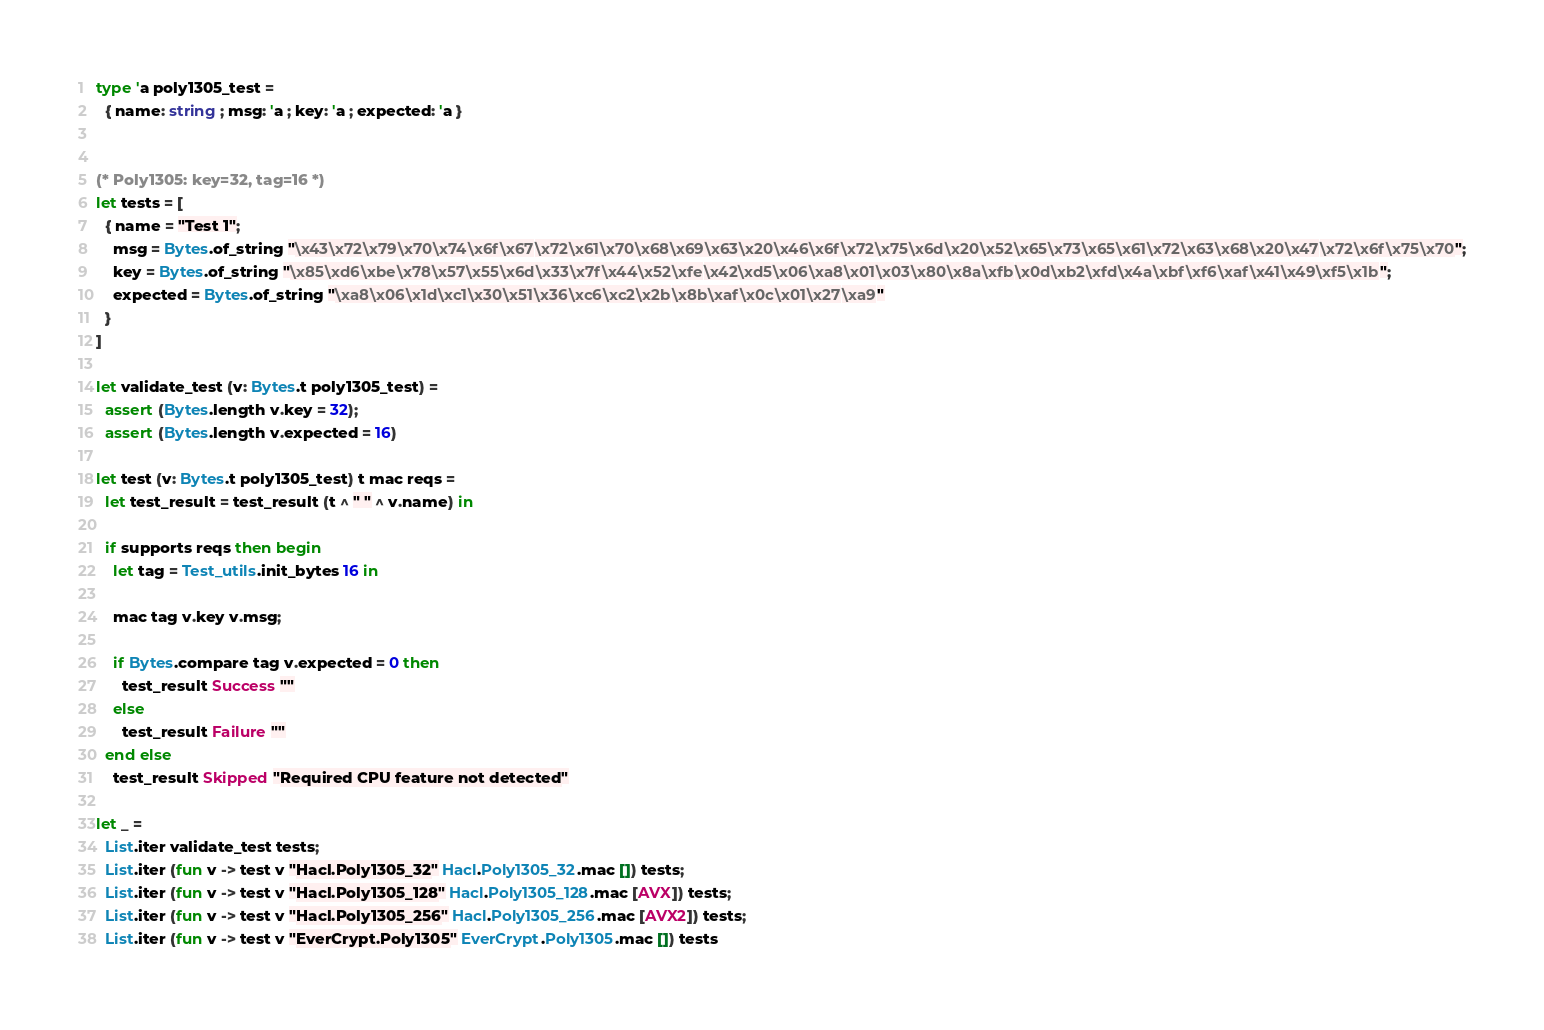Convert code to text. <code><loc_0><loc_0><loc_500><loc_500><_OCaml_>
type 'a poly1305_test =
  { name: string ; msg: 'a ; key: 'a ; expected: 'a }


(* Poly1305: key=32, tag=16 *)
let tests = [
  { name = "Test 1";
    msg = Bytes.of_string "\x43\x72\x79\x70\x74\x6f\x67\x72\x61\x70\x68\x69\x63\x20\x46\x6f\x72\x75\x6d\x20\x52\x65\x73\x65\x61\x72\x63\x68\x20\x47\x72\x6f\x75\x70";
    key = Bytes.of_string "\x85\xd6\xbe\x78\x57\x55\x6d\x33\x7f\x44\x52\xfe\x42\xd5\x06\xa8\x01\x03\x80\x8a\xfb\x0d\xb2\xfd\x4a\xbf\xf6\xaf\x41\x49\xf5\x1b";
    expected = Bytes.of_string "\xa8\x06\x1d\xc1\x30\x51\x36\xc6\xc2\x2b\x8b\xaf\x0c\x01\x27\xa9"
  }
]

let validate_test (v: Bytes.t poly1305_test) =
  assert (Bytes.length v.key = 32);
  assert (Bytes.length v.expected = 16)

let test (v: Bytes.t poly1305_test) t mac reqs =
  let test_result = test_result (t ^ " " ^ v.name) in

  if supports reqs then begin
    let tag = Test_utils.init_bytes 16 in

    mac tag v.key v.msg;

    if Bytes.compare tag v.expected = 0 then
      test_result Success ""
    else
      test_result Failure ""
  end else
    test_result Skipped "Required CPU feature not detected"

let _ =
  List.iter validate_test tests;
  List.iter (fun v -> test v "Hacl.Poly1305_32" Hacl.Poly1305_32.mac []) tests;
  List.iter (fun v -> test v "Hacl.Poly1305_128" Hacl.Poly1305_128.mac [AVX]) tests;
  List.iter (fun v -> test v "Hacl.Poly1305_256" Hacl.Poly1305_256.mac [AVX2]) tests;
  List.iter (fun v -> test v "EverCrypt.Poly1305" EverCrypt.Poly1305.mac []) tests
</code> 